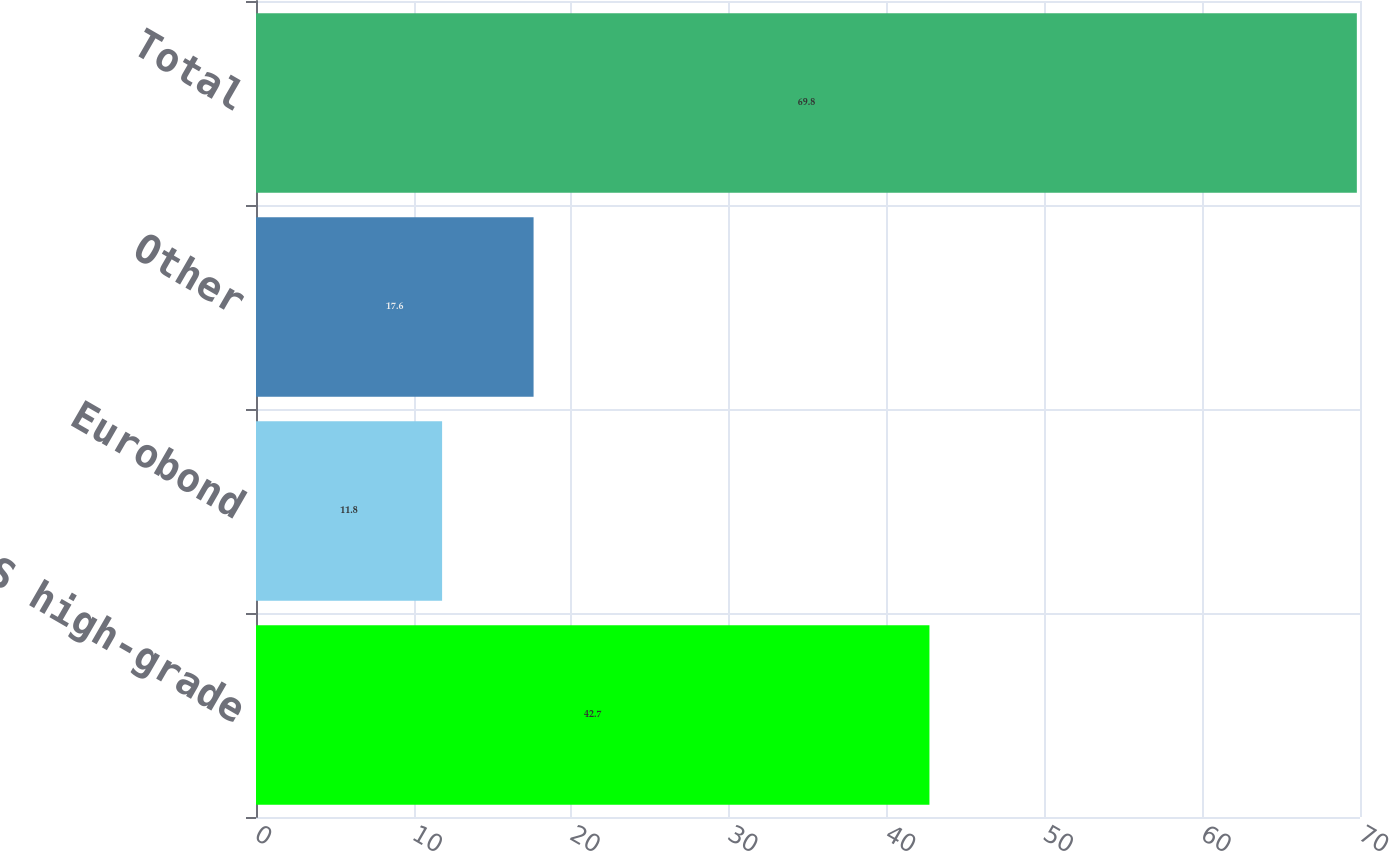<chart> <loc_0><loc_0><loc_500><loc_500><bar_chart><fcel>US high-grade<fcel>Eurobond<fcel>Other<fcel>Total<nl><fcel>42.7<fcel>11.8<fcel>17.6<fcel>69.8<nl></chart> 